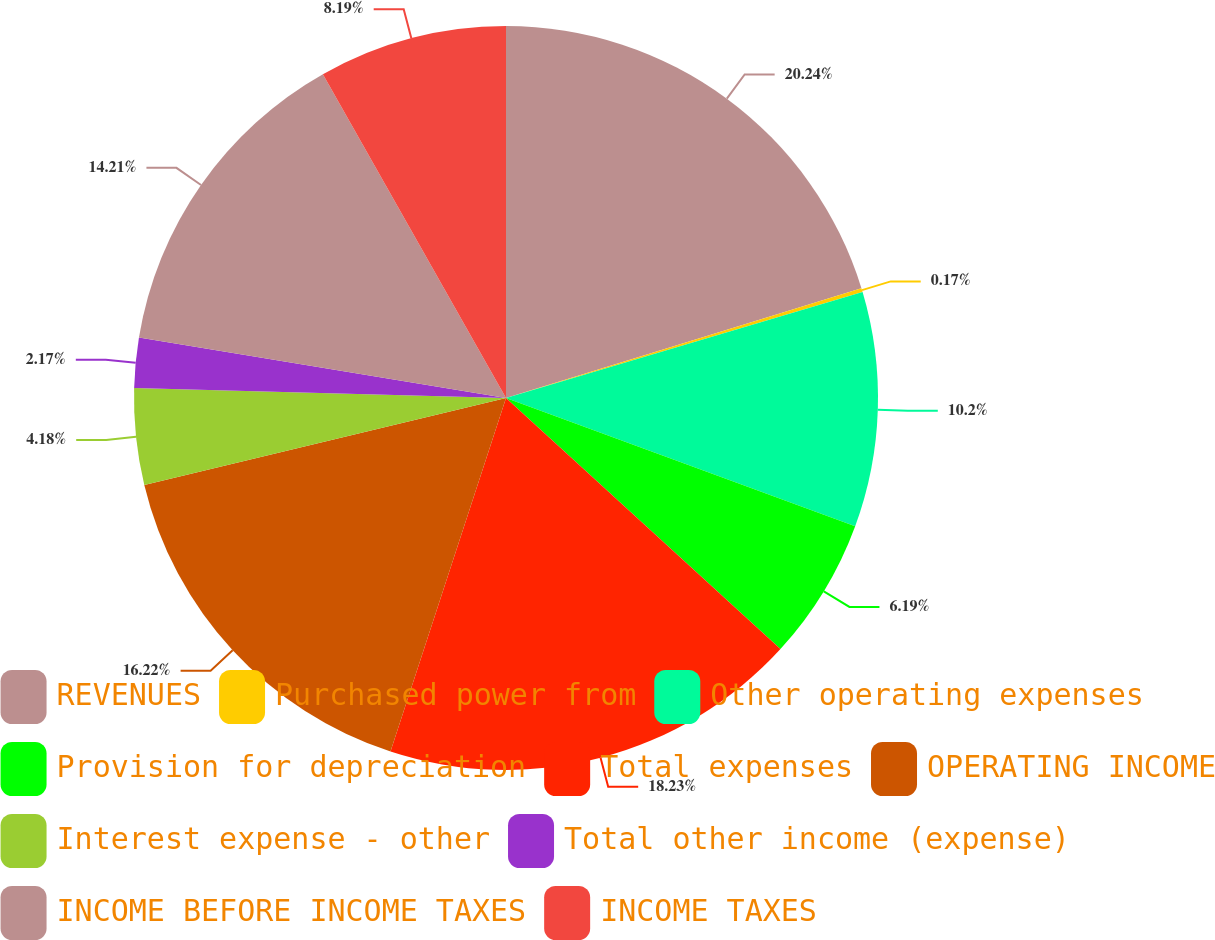<chart> <loc_0><loc_0><loc_500><loc_500><pie_chart><fcel>REVENUES<fcel>Purchased power from<fcel>Other operating expenses<fcel>Provision for depreciation<fcel>Total expenses<fcel>OPERATING INCOME<fcel>Interest expense - other<fcel>Total other income (expense)<fcel>INCOME BEFORE INCOME TAXES<fcel>INCOME TAXES<nl><fcel>20.23%<fcel>0.17%<fcel>10.2%<fcel>6.19%<fcel>18.23%<fcel>16.22%<fcel>4.18%<fcel>2.17%<fcel>14.21%<fcel>8.19%<nl></chart> 